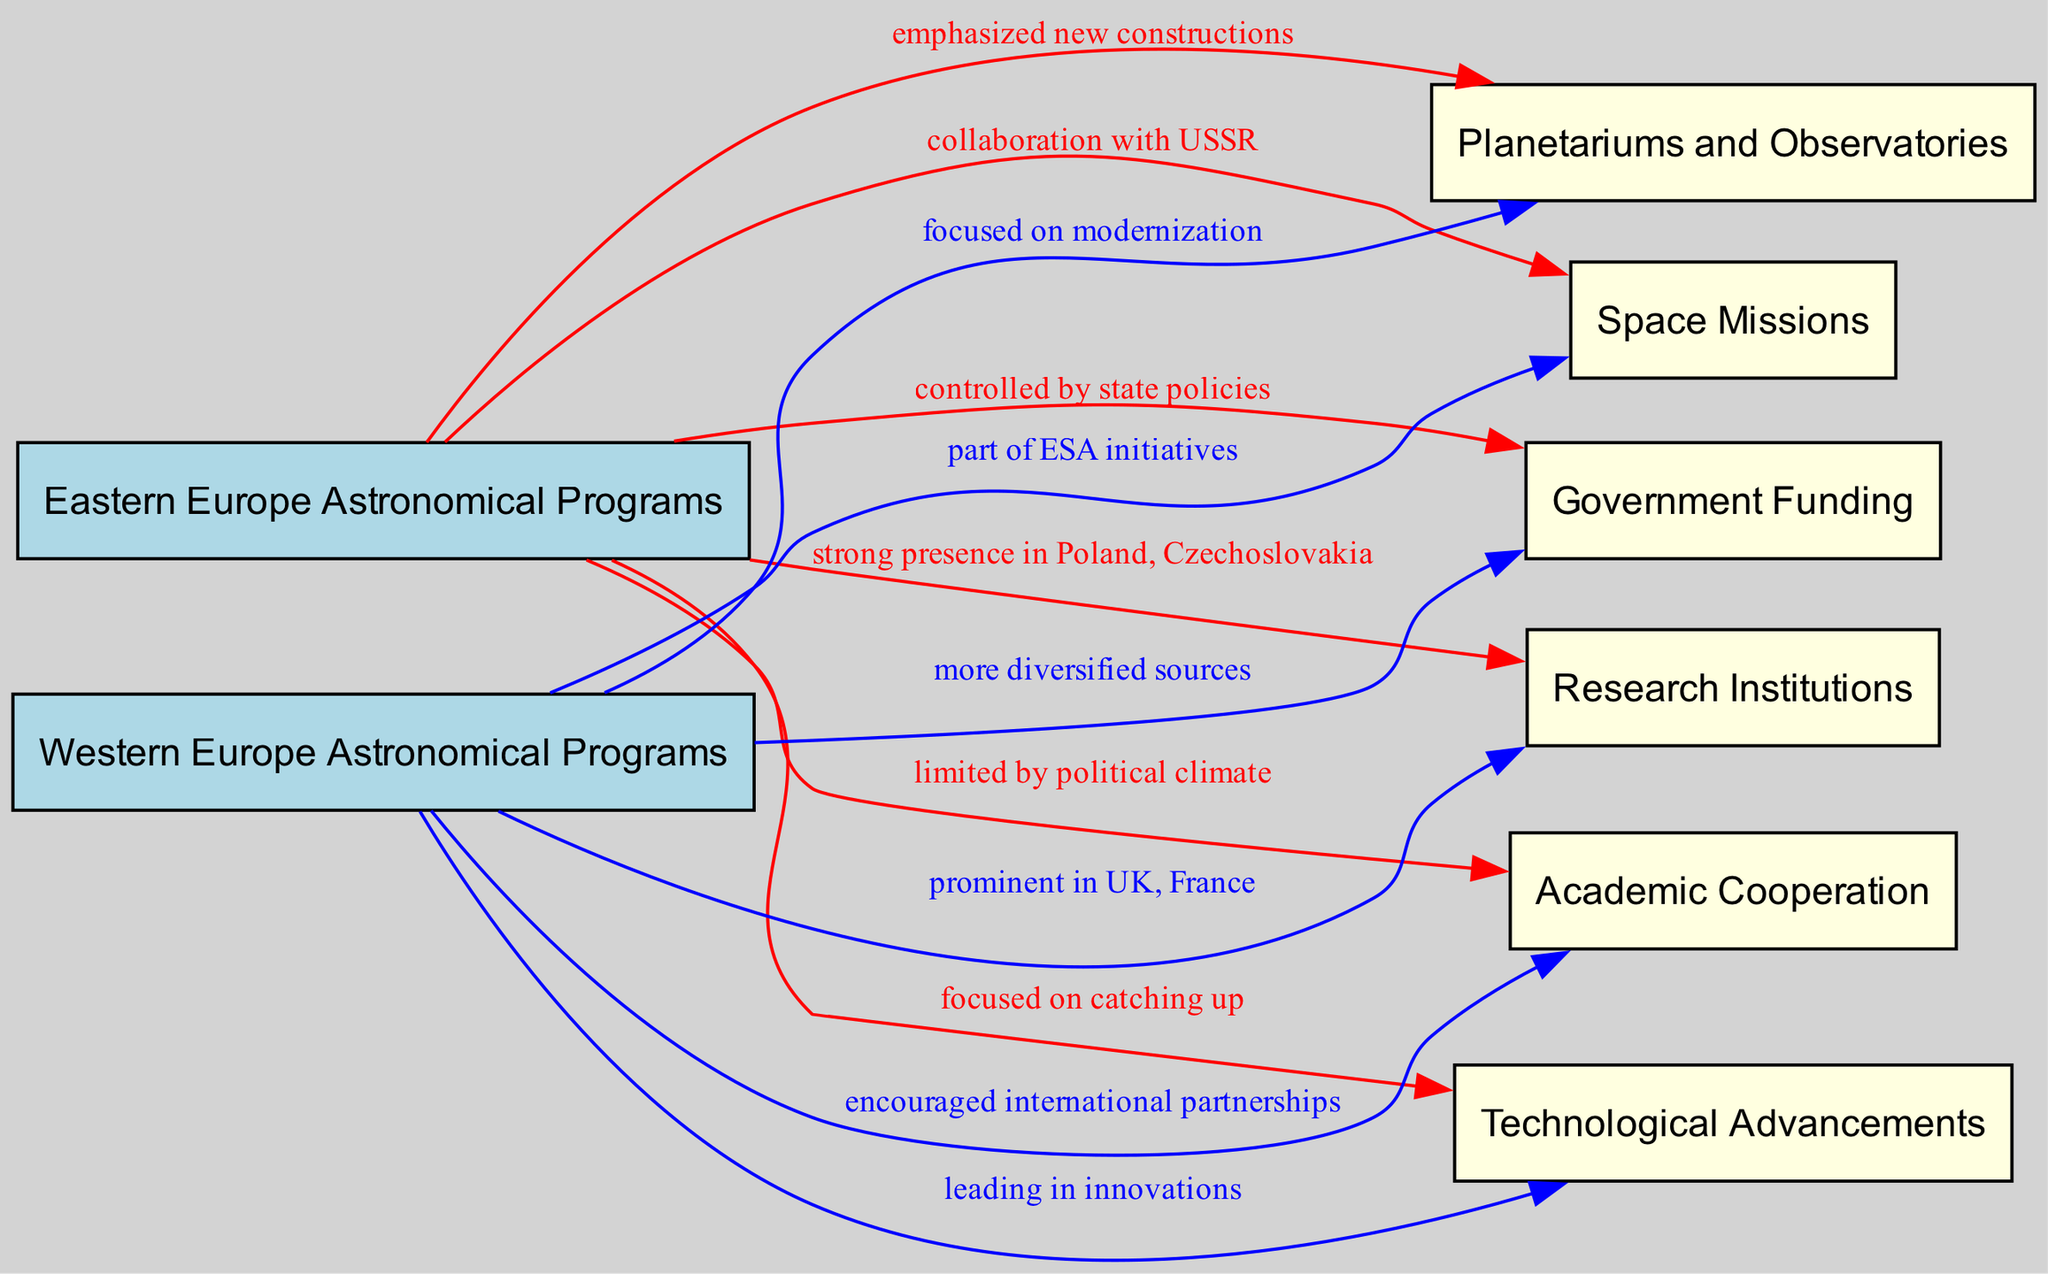What is the label for the Eastern Europe node in the diagram? The Eastern Europe node is labeled "Eastern Europe Astronomical Programs," which can be found at the left side of the diagram.
Answer: Eastern Europe Astronomical Programs How did Eastern Europe approach planetariums and observatories? The diagram indicates that Eastern Europe emphasized new constructions for planetariums and observatories, which is shown as an edge from the Eastern Europe node to the planetariums and observatories node.
Answer: emphasized new constructions What relationship does Western Europe have with academic cooperation? The diagram shows that Western Europe encouraged international partnerships in relation to academic cooperation, connected from the Western Europe node to this specific node in the diagram.
Answer: encouraged international partnerships Which geographic region has a stronger focus on technological advancements? By examining the connections, it is evident that Western Europe is depicted as leading in innovations in technological advancements, while Eastern Europe is focused on catching up. Thus, Western Europe has the stronger focus.
Answer: Western Europe How many types of funding sources are indicated for Western Europe? The diagram clearly states that Western Europe has more diversified sources for government funding. Since it is only one type discussed in the diagram, the answer is one.
Answer: one What type of missions were emphasized by Eastern Europe according to the diagram? The diagram indicates that Eastern Europe was characterized by collaboration with the USSR concerning space missions, which is depicted in the directed edge from Eastern Europe to space missions.
Answer: collaboration with USSR Identify the two prominent countries for research institutions in Eastern Europe. The diagram specifies that Eastern Europe had a strong presence in research institutions primarily in Poland and Czechoslovakia. Therefore, the two identified countries are Poland and Czechoslovakia.
Answer: Poland, Czechoslovakia How did Western Europe differ in their approach to space missions compared to Eastern Europe? The diagram illustrates that while Eastern Europe collaborated with the USSR for space missions, Western Europe was part of ESA initiatives, creating a distinct approach to space exploration in each region.
Answer: part of ESA initiatives What is the dependency of Eastern Europe's government funding as per the diagram? The diagram indicates that Eastern Europe's government funding is controlled by state policies, as labeled in the directed edge from Eastern Europe to the government funding node.
Answer: controlled by state policies 